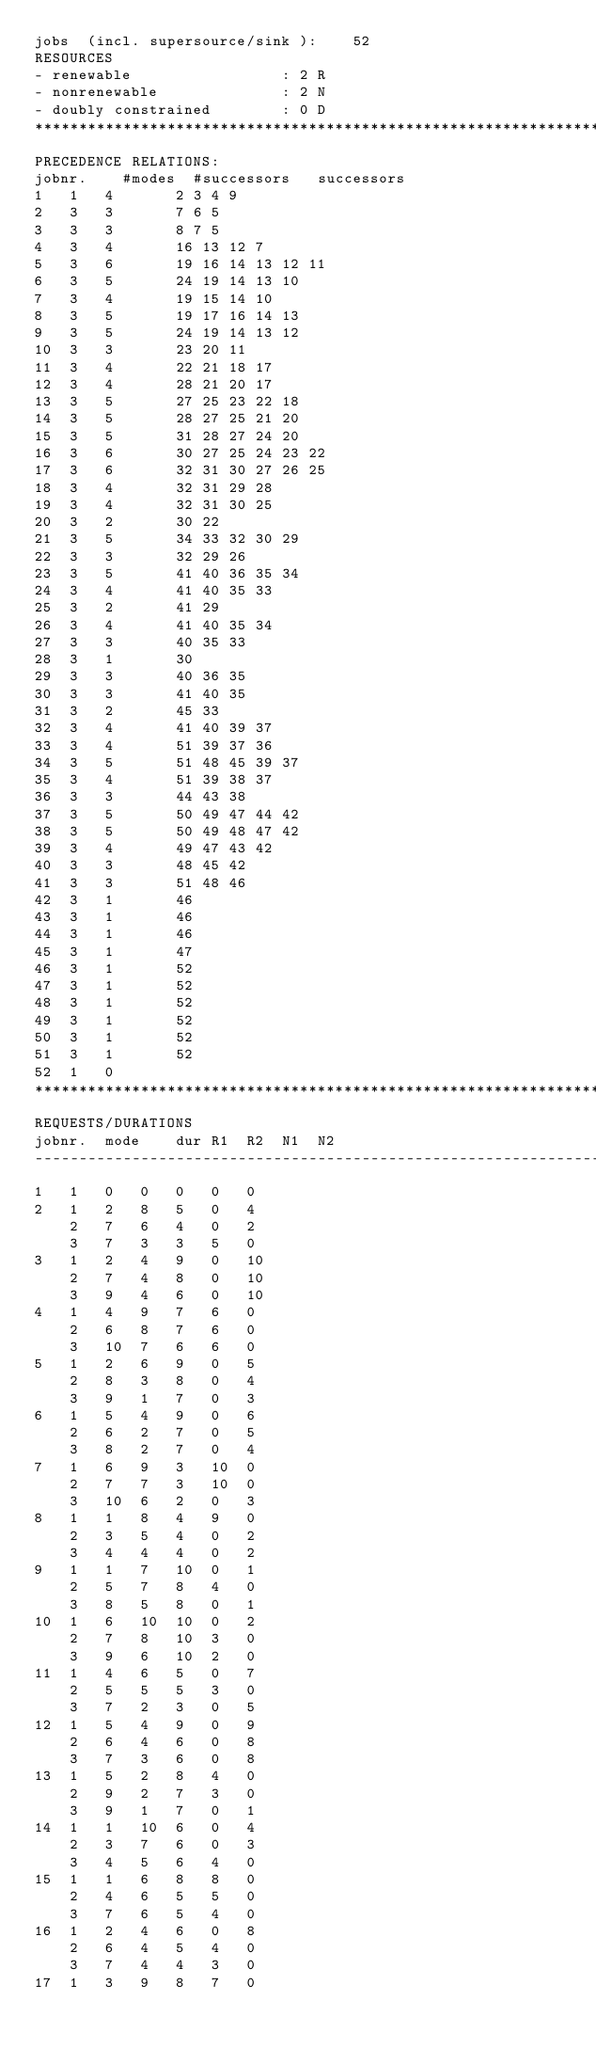<code> <loc_0><loc_0><loc_500><loc_500><_ObjectiveC_>jobs  (incl. supersource/sink ):	52
RESOURCES
- renewable                 : 2 R
- nonrenewable              : 2 N
- doubly constrained        : 0 D
************************************************************************
PRECEDENCE RELATIONS:
jobnr.    #modes  #successors   successors
1	1	4		2 3 4 9 
2	3	3		7 6 5 
3	3	3		8 7 5 
4	3	4		16 13 12 7 
5	3	6		19 16 14 13 12 11 
6	3	5		24 19 14 13 10 
7	3	4		19 15 14 10 
8	3	5		19 17 16 14 13 
9	3	5		24 19 14 13 12 
10	3	3		23 20 11 
11	3	4		22 21 18 17 
12	3	4		28 21 20 17 
13	3	5		27 25 23 22 18 
14	3	5		28 27 25 21 20 
15	3	5		31 28 27 24 20 
16	3	6		30 27 25 24 23 22 
17	3	6		32 31 30 27 26 25 
18	3	4		32 31 29 28 
19	3	4		32 31 30 25 
20	3	2		30 22 
21	3	5		34 33 32 30 29 
22	3	3		32 29 26 
23	3	5		41 40 36 35 34 
24	3	4		41 40 35 33 
25	3	2		41 29 
26	3	4		41 40 35 34 
27	3	3		40 35 33 
28	3	1		30 
29	3	3		40 36 35 
30	3	3		41 40 35 
31	3	2		45 33 
32	3	4		41 40 39 37 
33	3	4		51 39 37 36 
34	3	5		51 48 45 39 37 
35	3	4		51 39 38 37 
36	3	3		44 43 38 
37	3	5		50 49 47 44 42 
38	3	5		50 49 48 47 42 
39	3	4		49 47 43 42 
40	3	3		48 45 42 
41	3	3		51 48 46 
42	3	1		46 
43	3	1		46 
44	3	1		46 
45	3	1		47 
46	3	1		52 
47	3	1		52 
48	3	1		52 
49	3	1		52 
50	3	1		52 
51	3	1		52 
52	1	0		
************************************************************************
REQUESTS/DURATIONS
jobnr.	mode	dur	R1	R2	N1	N2	
------------------------------------------------------------------------
1	1	0	0	0	0	0	
2	1	2	8	5	0	4	
	2	7	6	4	0	2	
	3	7	3	3	5	0	
3	1	2	4	9	0	10	
	2	7	4	8	0	10	
	3	9	4	6	0	10	
4	1	4	9	7	6	0	
	2	6	8	7	6	0	
	3	10	7	6	6	0	
5	1	2	6	9	0	5	
	2	8	3	8	0	4	
	3	9	1	7	0	3	
6	1	5	4	9	0	6	
	2	6	2	7	0	5	
	3	8	2	7	0	4	
7	1	6	9	3	10	0	
	2	7	7	3	10	0	
	3	10	6	2	0	3	
8	1	1	8	4	9	0	
	2	3	5	4	0	2	
	3	4	4	4	0	2	
9	1	1	7	10	0	1	
	2	5	7	8	4	0	
	3	8	5	8	0	1	
10	1	6	10	10	0	2	
	2	7	8	10	3	0	
	3	9	6	10	2	0	
11	1	4	6	5	0	7	
	2	5	5	5	3	0	
	3	7	2	3	0	5	
12	1	5	4	9	0	9	
	2	6	4	6	0	8	
	3	7	3	6	0	8	
13	1	5	2	8	4	0	
	2	9	2	7	3	0	
	3	9	1	7	0	1	
14	1	1	10	6	0	4	
	2	3	7	6	0	3	
	3	4	5	6	4	0	
15	1	1	6	8	8	0	
	2	4	6	5	5	0	
	3	7	6	5	4	0	
16	1	2	4	6	0	8	
	2	6	4	5	4	0	
	3	7	4	4	3	0	
17	1	3	9	8	7	0	</code> 